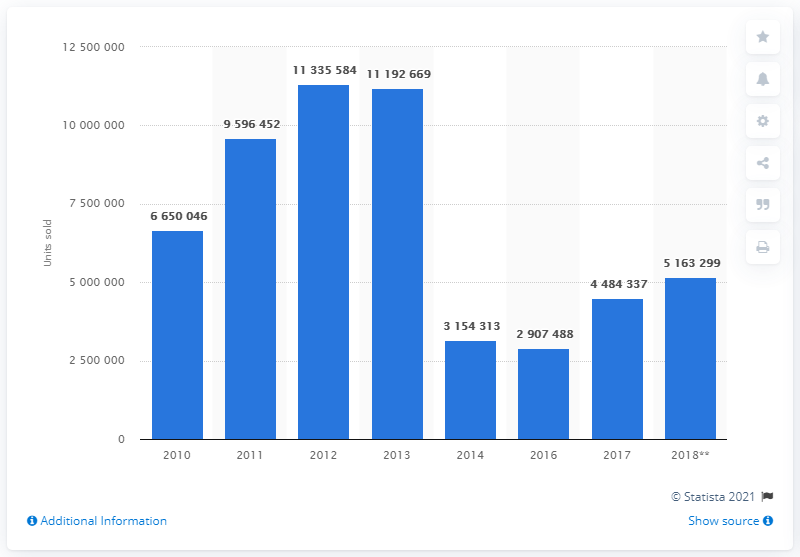Indicate a few pertinent items in this graphic. The sales volume of safety seat belts in the UK in 2018 was 516,329.9. In 2014, the United Kingdom witnessed a significant decline in the sales of safety seat belts. 